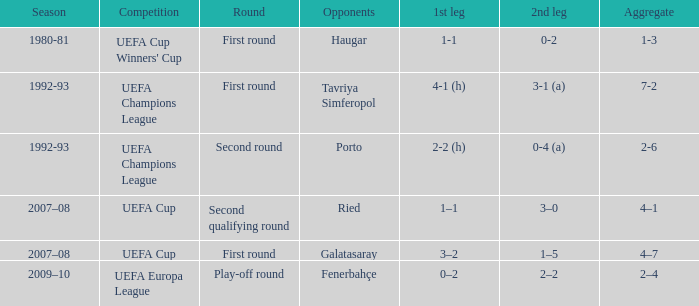What is the overall score with a 3-2 outcome in the first leg? 4–7. 